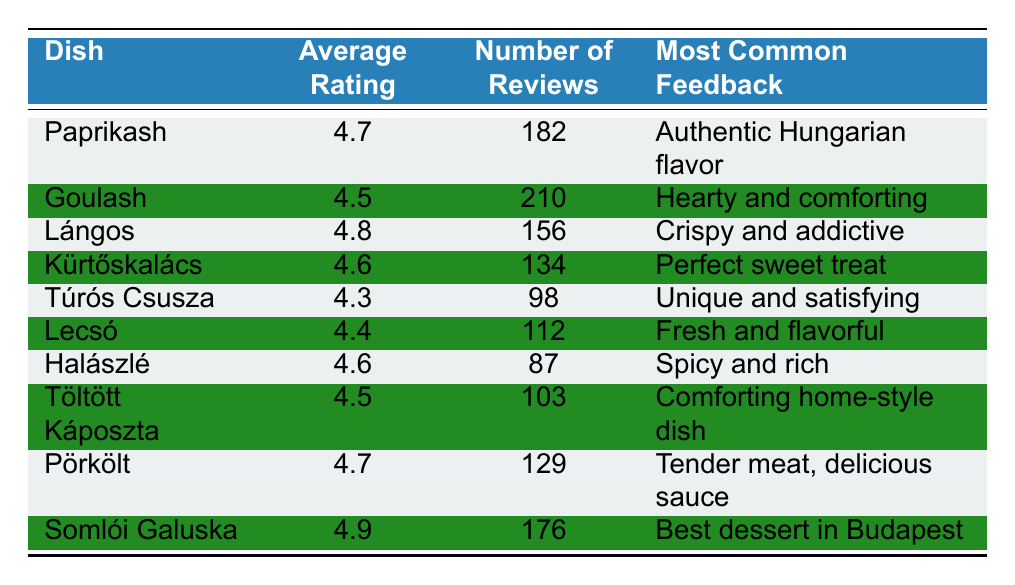What is the average rating of Lángos? According to the table, Lángos has an average rating of 4.8.
Answer: 4.8 How many reviews did the dish Kürtőskalács receive? The table shows that Kürtőskalács received 134 reviews.
Answer: 134 Which dish has the highest average rating? From the table, Somlói Galuska has the highest average rating of 4.9.
Answer: Somlói Galuska Is the average rating for Túrós Csusza greater than 4.5? The table indicates that Túrós Csusza has an average rating of 4.3, which is less than 4.5. Therefore, the statement is false.
Answer: No What is the average rating of all dishes combined? To find the average rating, sum the average ratings of all dishes: (4.7 + 4.5 + 4.8 + 4.6 + 4.3 + 4.4 + 4.6 + 4.5 + 4.7 + 4.9) = 46.5. There are 10 dishes, so the average is 46.5 / 10 = 4.65.
Answer: 4.65 How many dishes have an average rating of 4.6 or higher? The dishes that meet this criterion are Paprikash, Lángos, Kürtőskalács, Halászlé, Pörkölt, and Somlói Galuska. Counting these gives us a total of 6 dishes.
Answer: 6 What feedback is most common for the dish Pörkölt? The table states that the most common feedback for Pörkölt is "Tender meat, delicious sauce."
Answer: Tender meat, delicious sauce If you wanted to promote the dish that has the least number of reviews, which dish would it be? The dish with the least number of reviews is Halászlé, which has only 87 reviews. Therefore, Halászlé should be promoted.
Answer: Halászlé How does the average rating of Goulash compare with that of Lecsó? Goulash has an average rating of 4.5 and Lecsó has 4.4. Since 4.5 is greater than 4.4, Goulash has a higher average rating.
Answer: Goulash is higher 